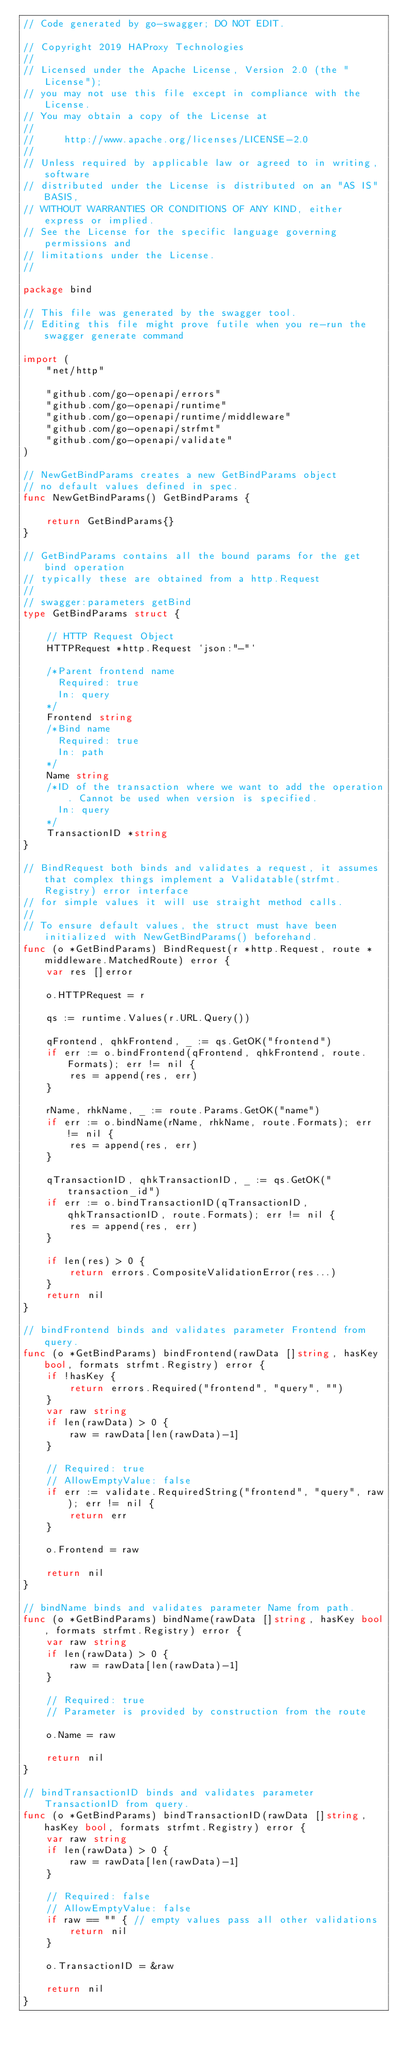Convert code to text. <code><loc_0><loc_0><loc_500><loc_500><_Go_>// Code generated by go-swagger; DO NOT EDIT.

// Copyright 2019 HAProxy Technologies
//
// Licensed under the Apache License, Version 2.0 (the "License");
// you may not use this file except in compliance with the License.
// You may obtain a copy of the License at
//
//     http://www.apache.org/licenses/LICENSE-2.0
//
// Unless required by applicable law or agreed to in writing, software
// distributed under the License is distributed on an "AS IS" BASIS,
// WITHOUT WARRANTIES OR CONDITIONS OF ANY KIND, either express or implied.
// See the License for the specific language governing permissions and
// limitations under the License.
//

package bind

// This file was generated by the swagger tool.
// Editing this file might prove futile when you re-run the swagger generate command

import (
	"net/http"

	"github.com/go-openapi/errors"
	"github.com/go-openapi/runtime"
	"github.com/go-openapi/runtime/middleware"
	"github.com/go-openapi/strfmt"
	"github.com/go-openapi/validate"
)

// NewGetBindParams creates a new GetBindParams object
// no default values defined in spec.
func NewGetBindParams() GetBindParams {

	return GetBindParams{}
}

// GetBindParams contains all the bound params for the get bind operation
// typically these are obtained from a http.Request
//
// swagger:parameters getBind
type GetBindParams struct {

	// HTTP Request Object
	HTTPRequest *http.Request `json:"-"`

	/*Parent frontend name
	  Required: true
	  In: query
	*/
	Frontend string
	/*Bind name
	  Required: true
	  In: path
	*/
	Name string
	/*ID of the transaction where we want to add the operation. Cannot be used when version is specified.
	  In: query
	*/
	TransactionID *string
}

// BindRequest both binds and validates a request, it assumes that complex things implement a Validatable(strfmt.Registry) error interface
// for simple values it will use straight method calls.
//
// To ensure default values, the struct must have been initialized with NewGetBindParams() beforehand.
func (o *GetBindParams) BindRequest(r *http.Request, route *middleware.MatchedRoute) error {
	var res []error

	o.HTTPRequest = r

	qs := runtime.Values(r.URL.Query())

	qFrontend, qhkFrontend, _ := qs.GetOK("frontend")
	if err := o.bindFrontend(qFrontend, qhkFrontend, route.Formats); err != nil {
		res = append(res, err)
	}

	rName, rhkName, _ := route.Params.GetOK("name")
	if err := o.bindName(rName, rhkName, route.Formats); err != nil {
		res = append(res, err)
	}

	qTransactionID, qhkTransactionID, _ := qs.GetOK("transaction_id")
	if err := o.bindTransactionID(qTransactionID, qhkTransactionID, route.Formats); err != nil {
		res = append(res, err)
	}

	if len(res) > 0 {
		return errors.CompositeValidationError(res...)
	}
	return nil
}

// bindFrontend binds and validates parameter Frontend from query.
func (o *GetBindParams) bindFrontend(rawData []string, hasKey bool, formats strfmt.Registry) error {
	if !hasKey {
		return errors.Required("frontend", "query", "")
	}
	var raw string
	if len(rawData) > 0 {
		raw = rawData[len(rawData)-1]
	}

	// Required: true
	// AllowEmptyValue: false
	if err := validate.RequiredString("frontend", "query", raw); err != nil {
		return err
	}

	o.Frontend = raw

	return nil
}

// bindName binds and validates parameter Name from path.
func (o *GetBindParams) bindName(rawData []string, hasKey bool, formats strfmt.Registry) error {
	var raw string
	if len(rawData) > 0 {
		raw = rawData[len(rawData)-1]
	}

	// Required: true
	// Parameter is provided by construction from the route

	o.Name = raw

	return nil
}

// bindTransactionID binds and validates parameter TransactionID from query.
func (o *GetBindParams) bindTransactionID(rawData []string, hasKey bool, formats strfmt.Registry) error {
	var raw string
	if len(rawData) > 0 {
		raw = rawData[len(rawData)-1]
	}

	// Required: false
	// AllowEmptyValue: false
	if raw == "" { // empty values pass all other validations
		return nil
	}

	o.TransactionID = &raw

	return nil
}
</code> 